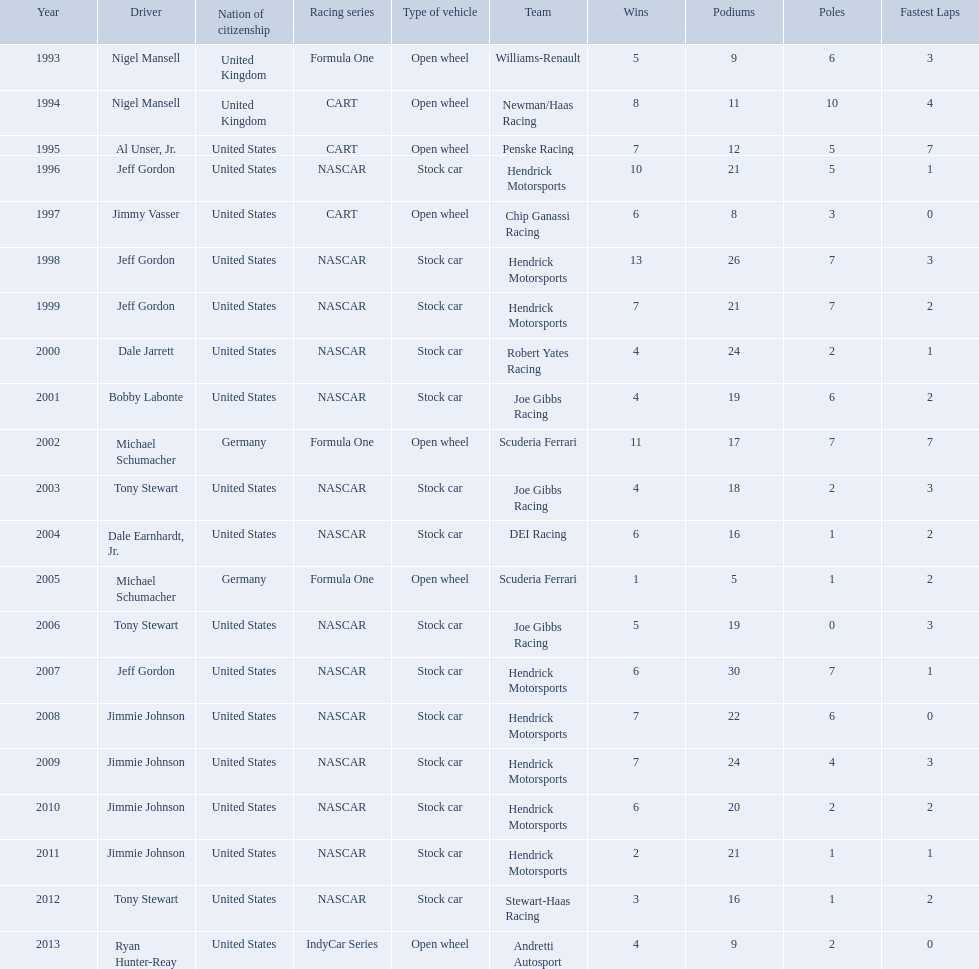Which drivers have won the best driver espy award? Nigel Mansell, Nigel Mansell, Al Unser, Jr., Jeff Gordon, Jimmy Vasser, Jeff Gordon, Jeff Gordon, Dale Jarrett, Bobby Labonte, Michael Schumacher, Tony Stewart, Dale Earnhardt, Jr., Michael Schumacher, Tony Stewart, Jeff Gordon, Jimmie Johnson, Jimmie Johnson, Jimmie Johnson, Jimmie Johnson, Tony Stewart, Ryan Hunter-Reay. Of these, which only appear once? Al Unser, Jr., Jimmy Vasser, Dale Jarrett, Dale Earnhardt, Jr., Ryan Hunter-Reay. Which of these are from the cart racing series? Al Unser, Jr., Jimmy Vasser. Of these, which received their award first? Al Unser, Jr. 